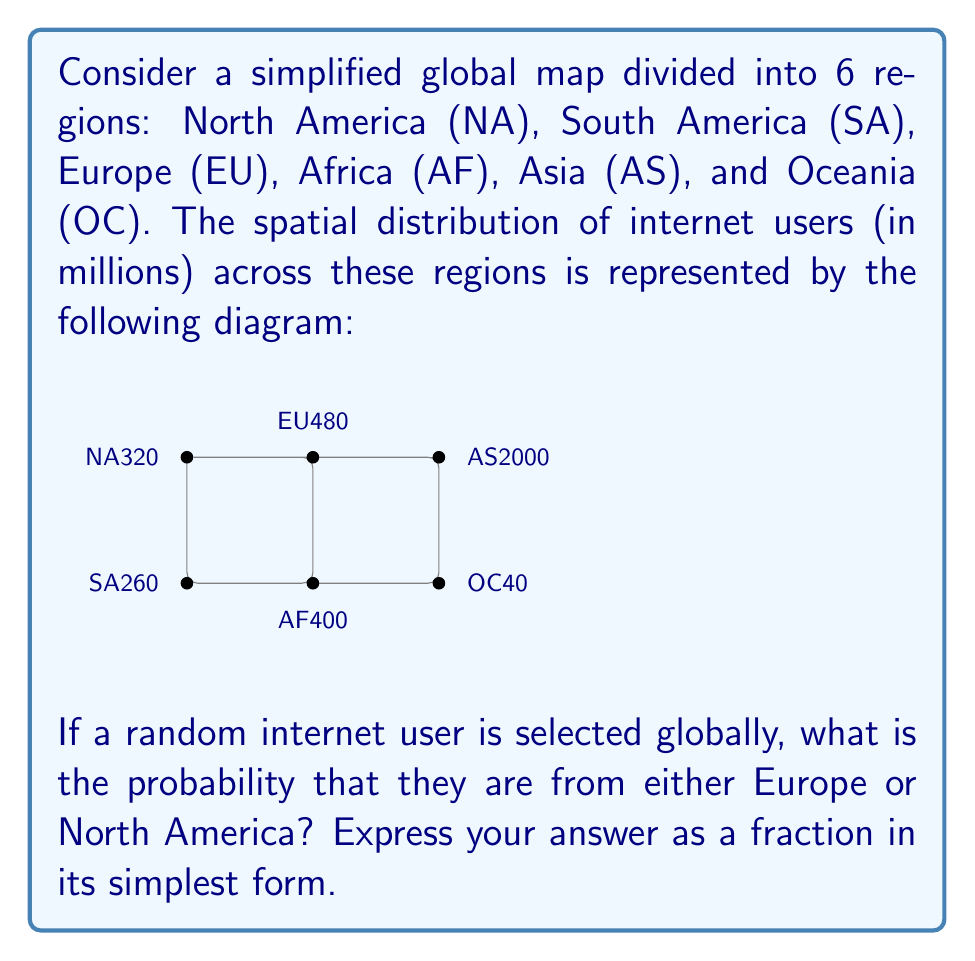Can you answer this question? To solve this problem, we need to follow these steps:

1. Calculate the total number of internet users globally:
   $$Total = 320 + 260 + 480 + 400 + 2000 + 40 = 3500$$ million users

2. Identify the number of users in Europe and North America:
   $$EU + NA = 480 + 320 = 800$$ million users

3. Calculate the probability by dividing the users in EU and NA by the total:
   $$P(EU \text{ or } NA) = \frac{800}{3500}$$

4. Simplify the fraction:
   $$\frac{800}{3500} = \frac{16}{70} = \frac{8}{35}$$

Therefore, the probability of selecting an internet user from either Europe or North America is $\frac{8}{35}$.
Answer: $\frac{8}{35}$ 